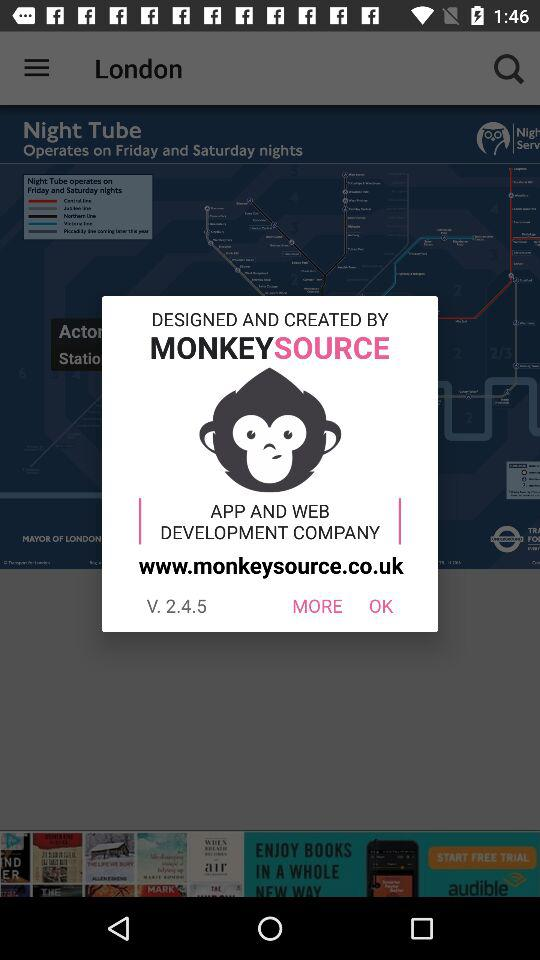What is the app name in the advertisement? The app name in the advertisement is "audible". 